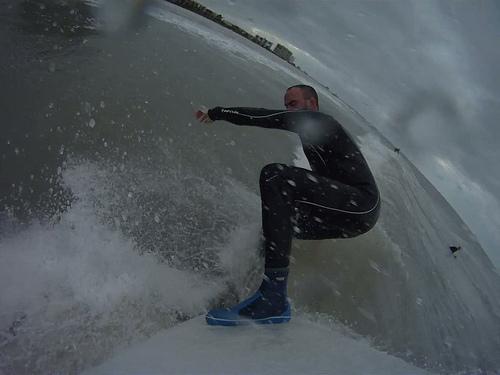Is he surfing?
Quick response, please. Yes. Is it sunny on this beach?
Be succinct. No. Is the camera being held by a person?
Be succinct. No. 